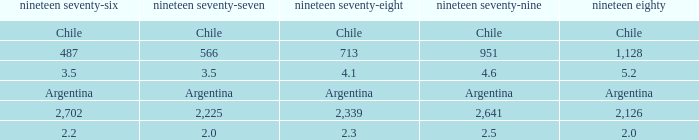What is 1977 when 1980 is chile? Chile. 